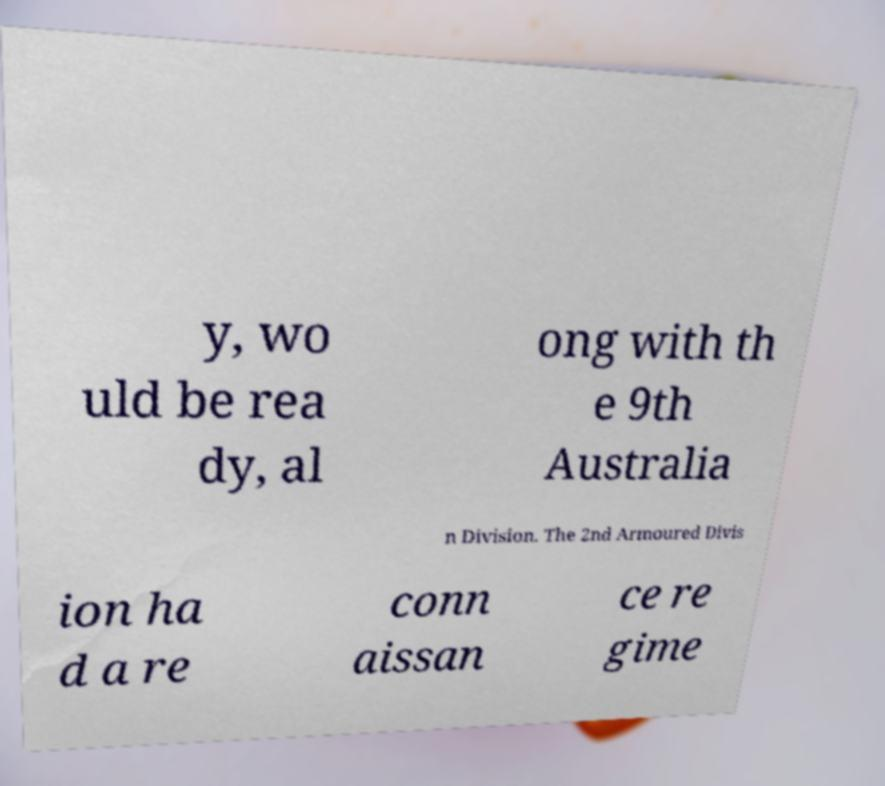Please read and relay the text visible in this image. What does it say? y, wo uld be rea dy, al ong with th e 9th Australia n Division. The 2nd Armoured Divis ion ha d a re conn aissan ce re gime 